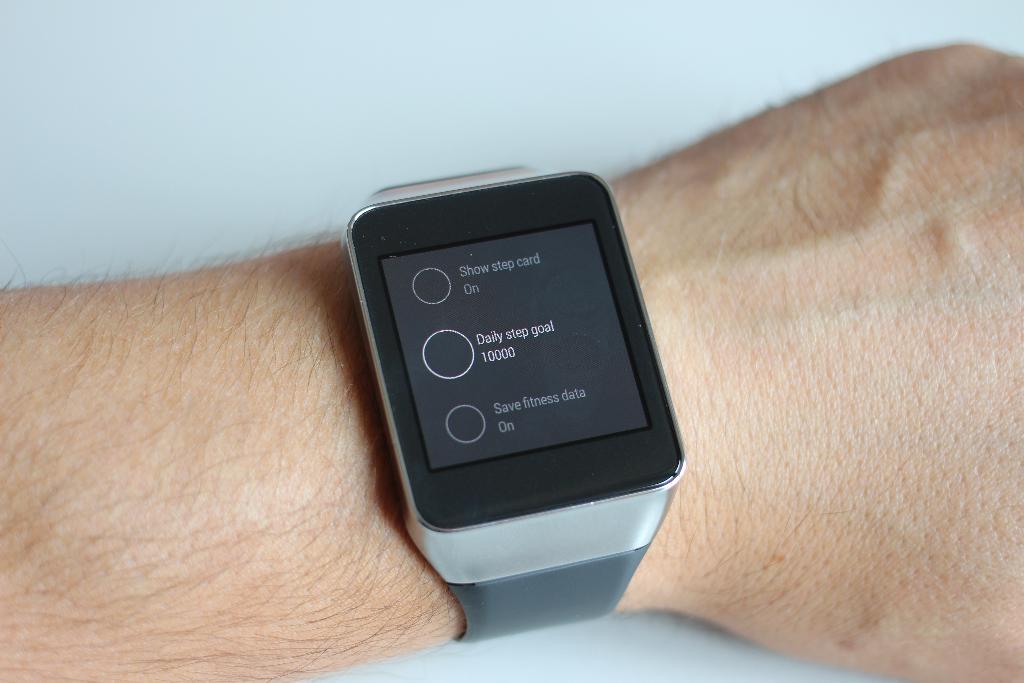What is written on the watch's screen currently?
Provide a succinct answer. Daily step goal. Is this a smart watch?
Make the answer very short. Answering does not require reading text in the image. 